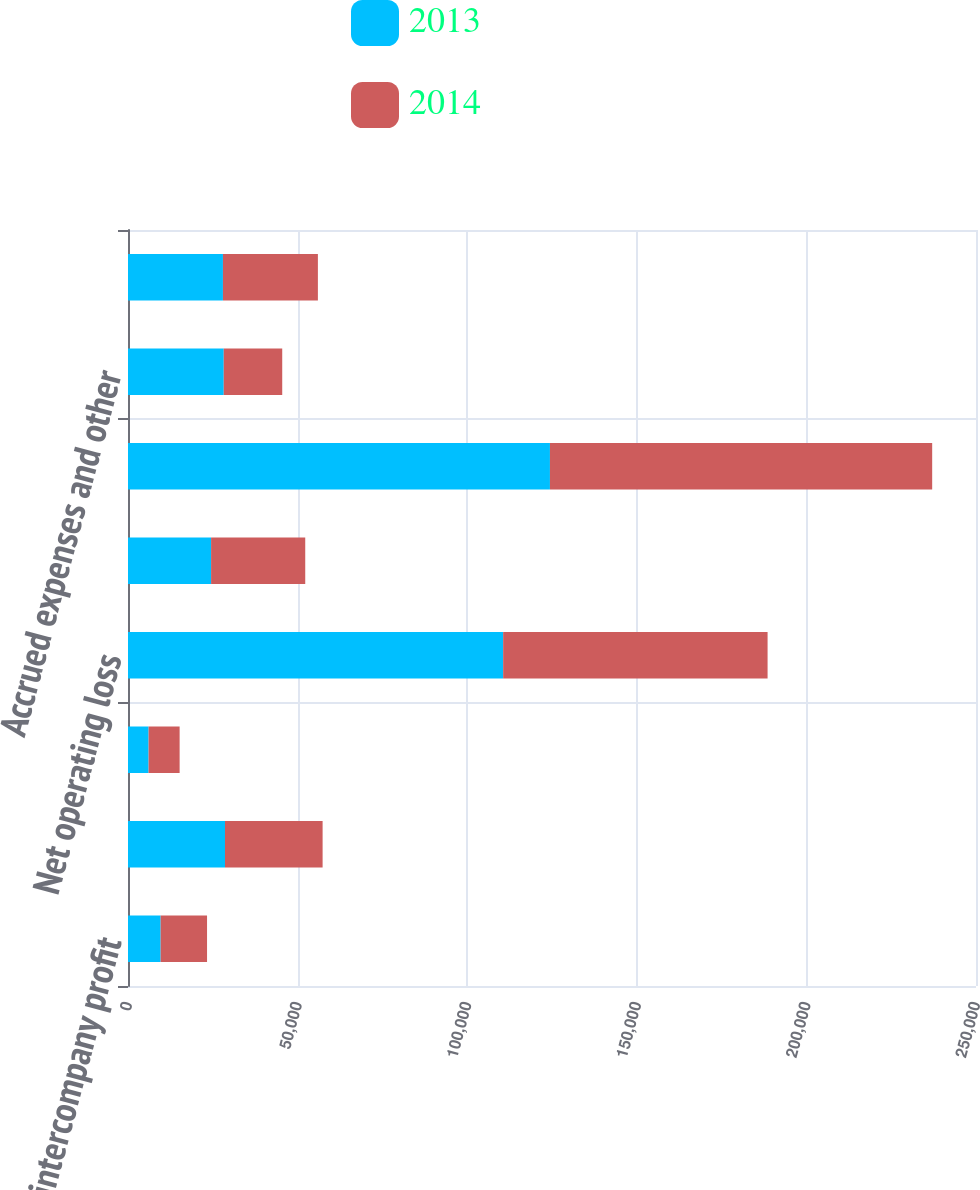Convert chart to OTSL. <chart><loc_0><loc_0><loc_500><loc_500><stacked_bar_chart><ecel><fcel>Deferred intercompany profit<fcel>Deferred income on shipments<fcel>Inventory valuation<fcel>Net operating loss<fcel>Share-based compensation<fcel>Income tax credits<fcel>Accrued expenses and other<fcel>Gross deferred tax assets<nl><fcel>2013<fcel>9623<fcel>28596<fcel>6072<fcel>110598<fcel>24494<fcel>124395<fcel>28227<fcel>27992<nl><fcel>2014<fcel>13679<fcel>28776<fcel>9148<fcel>77959<fcel>27757<fcel>112686<fcel>17241<fcel>27992<nl></chart> 